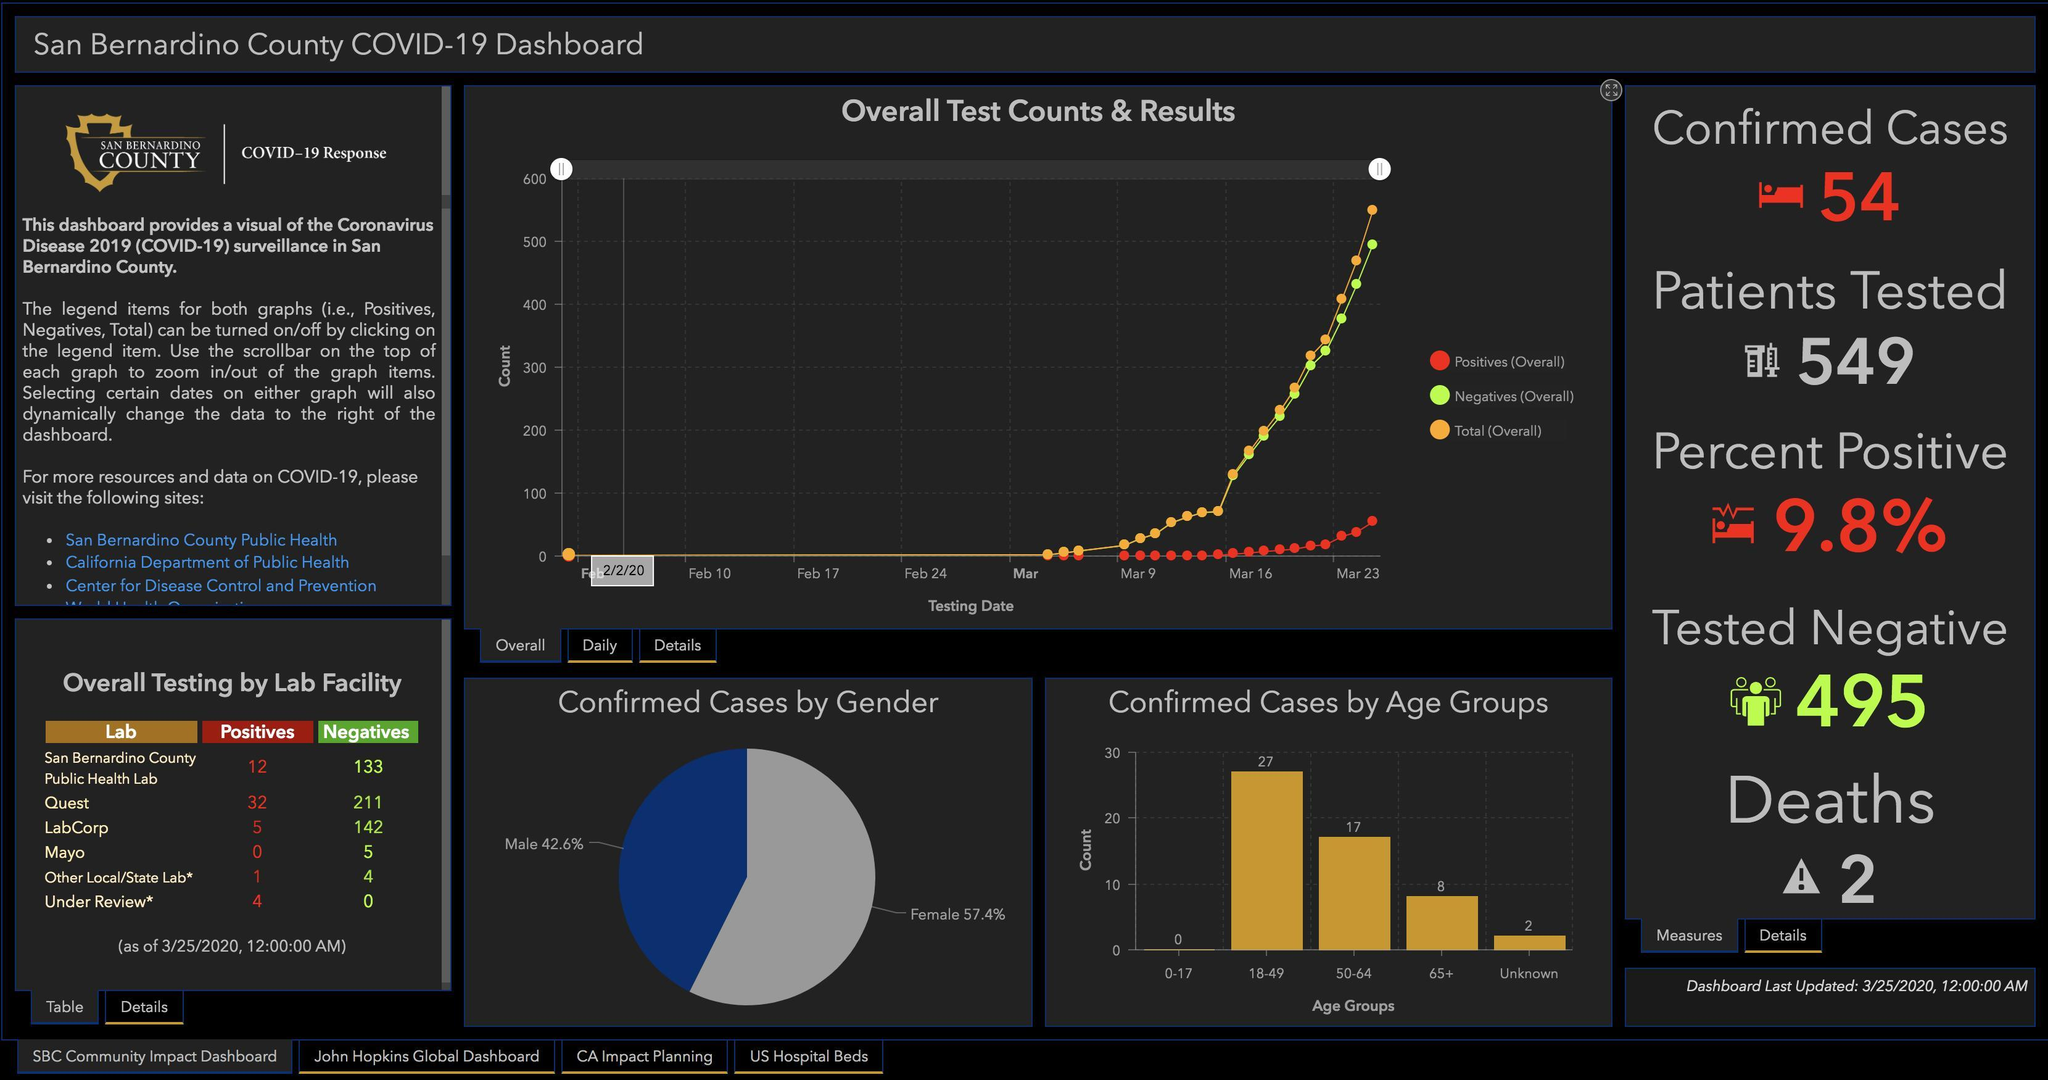what is the total number of negative cases from all the labs?
Answer the question with a short phrase. 495 Which lab reported most number of positive cases? quest what is the number of infected people over the age of 18? 52 Which lab tested most number of samples? Quest what is the number of infected people over the age of 50? 25 Which lab reported least number of positive cases? mayo what is the number of infected people under the age of 65? 44 Which lab reported most number of negative cases? quest Which age group is more infected by COVID-19? 18-49 Who is more infected by COVID-19 - men or women? women 